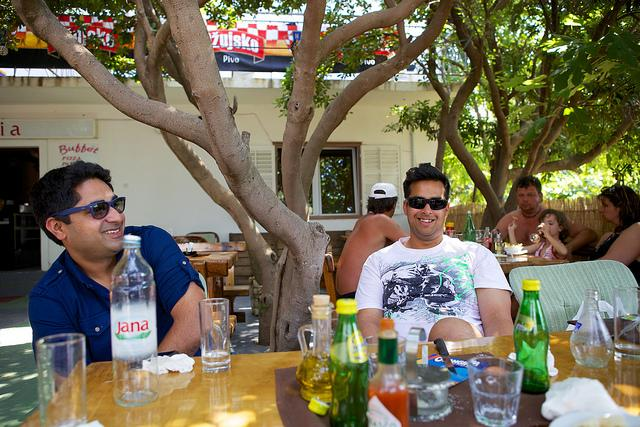What establishment is located behind the people? restaurant 